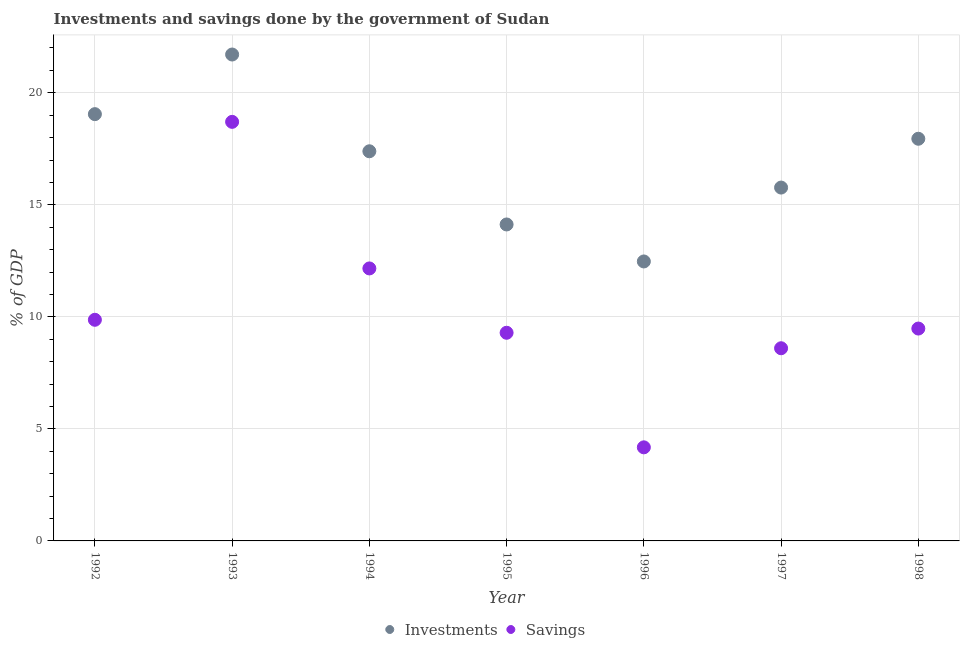How many different coloured dotlines are there?
Provide a succinct answer. 2. Is the number of dotlines equal to the number of legend labels?
Provide a short and direct response. Yes. What is the investments of government in 1992?
Offer a terse response. 19.05. Across all years, what is the maximum investments of government?
Keep it short and to the point. 21.71. Across all years, what is the minimum investments of government?
Your answer should be very brief. 12.47. In which year was the investments of government maximum?
Provide a succinct answer. 1993. In which year was the savings of government minimum?
Keep it short and to the point. 1996. What is the total savings of government in the graph?
Provide a short and direct response. 72.28. What is the difference between the savings of government in 1992 and that in 1995?
Your response must be concise. 0.58. What is the difference between the savings of government in 1993 and the investments of government in 1998?
Your answer should be very brief. 0.75. What is the average investments of government per year?
Ensure brevity in your answer.  16.92. In the year 1998, what is the difference between the savings of government and investments of government?
Offer a terse response. -8.47. What is the ratio of the savings of government in 1995 to that in 1997?
Offer a terse response. 1.08. Is the savings of government in 1994 less than that in 1995?
Your answer should be very brief. No. Is the difference between the savings of government in 1994 and 1997 greater than the difference between the investments of government in 1994 and 1997?
Your answer should be compact. Yes. What is the difference between the highest and the second highest savings of government?
Offer a very short reply. 6.54. What is the difference between the highest and the lowest investments of government?
Make the answer very short. 9.24. In how many years, is the savings of government greater than the average savings of government taken over all years?
Provide a succinct answer. 2. Does the savings of government monotonically increase over the years?
Provide a succinct answer. No. Is the investments of government strictly greater than the savings of government over the years?
Your answer should be very brief. Yes. How many dotlines are there?
Ensure brevity in your answer.  2. How many years are there in the graph?
Provide a short and direct response. 7. What is the difference between two consecutive major ticks on the Y-axis?
Keep it short and to the point. 5. Are the values on the major ticks of Y-axis written in scientific E-notation?
Keep it short and to the point. No. Does the graph contain grids?
Your answer should be compact. Yes. Where does the legend appear in the graph?
Offer a very short reply. Bottom center. How are the legend labels stacked?
Your response must be concise. Horizontal. What is the title of the graph?
Give a very brief answer. Investments and savings done by the government of Sudan. Does "From production" appear as one of the legend labels in the graph?
Ensure brevity in your answer.  No. What is the label or title of the Y-axis?
Offer a terse response. % of GDP. What is the % of GDP in Investments in 1992?
Your answer should be compact. 19.05. What is the % of GDP of Savings in 1992?
Ensure brevity in your answer.  9.87. What is the % of GDP of Investments in 1993?
Ensure brevity in your answer.  21.71. What is the % of GDP in Savings in 1993?
Provide a short and direct response. 18.7. What is the % of GDP of Investments in 1994?
Your answer should be very brief. 17.39. What is the % of GDP of Savings in 1994?
Keep it short and to the point. 12.16. What is the % of GDP in Investments in 1995?
Your response must be concise. 14.12. What is the % of GDP of Savings in 1995?
Your response must be concise. 9.29. What is the % of GDP of Investments in 1996?
Offer a terse response. 12.47. What is the % of GDP in Savings in 1996?
Ensure brevity in your answer.  4.18. What is the % of GDP of Investments in 1997?
Keep it short and to the point. 15.77. What is the % of GDP in Savings in 1997?
Offer a very short reply. 8.6. What is the % of GDP in Investments in 1998?
Ensure brevity in your answer.  17.95. What is the % of GDP in Savings in 1998?
Give a very brief answer. 9.48. Across all years, what is the maximum % of GDP in Investments?
Offer a very short reply. 21.71. Across all years, what is the maximum % of GDP in Savings?
Keep it short and to the point. 18.7. Across all years, what is the minimum % of GDP in Investments?
Your response must be concise. 12.47. Across all years, what is the minimum % of GDP in Savings?
Your response must be concise. 4.18. What is the total % of GDP of Investments in the graph?
Ensure brevity in your answer.  118.46. What is the total % of GDP in Savings in the graph?
Provide a succinct answer. 72.28. What is the difference between the % of GDP in Investments in 1992 and that in 1993?
Offer a terse response. -2.66. What is the difference between the % of GDP in Savings in 1992 and that in 1993?
Keep it short and to the point. -8.83. What is the difference between the % of GDP of Investments in 1992 and that in 1994?
Keep it short and to the point. 1.66. What is the difference between the % of GDP of Savings in 1992 and that in 1994?
Offer a terse response. -2.29. What is the difference between the % of GDP in Investments in 1992 and that in 1995?
Provide a succinct answer. 4.92. What is the difference between the % of GDP of Savings in 1992 and that in 1995?
Your answer should be compact. 0.58. What is the difference between the % of GDP in Investments in 1992 and that in 1996?
Give a very brief answer. 6.57. What is the difference between the % of GDP in Savings in 1992 and that in 1996?
Make the answer very short. 5.69. What is the difference between the % of GDP in Investments in 1992 and that in 1997?
Your answer should be very brief. 3.28. What is the difference between the % of GDP in Savings in 1992 and that in 1997?
Offer a terse response. 1.27. What is the difference between the % of GDP in Investments in 1992 and that in 1998?
Keep it short and to the point. 1.1. What is the difference between the % of GDP of Savings in 1992 and that in 1998?
Your answer should be compact. 0.39. What is the difference between the % of GDP of Investments in 1993 and that in 1994?
Ensure brevity in your answer.  4.32. What is the difference between the % of GDP of Savings in 1993 and that in 1994?
Give a very brief answer. 6.54. What is the difference between the % of GDP in Investments in 1993 and that in 1995?
Your answer should be compact. 7.59. What is the difference between the % of GDP of Savings in 1993 and that in 1995?
Your response must be concise. 9.41. What is the difference between the % of GDP of Investments in 1993 and that in 1996?
Make the answer very short. 9.24. What is the difference between the % of GDP in Savings in 1993 and that in 1996?
Your answer should be compact. 14.53. What is the difference between the % of GDP in Investments in 1993 and that in 1997?
Offer a very short reply. 5.94. What is the difference between the % of GDP in Savings in 1993 and that in 1997?
Your response must be concise. 10.1. What is the difference between the % of GDP of Investments in 1993 and that in 1998?
Your answer should be compact. 3.76. What is the difference between the % of GDP of Savings in 1993 and that in 1998?
Offer a terse response. 9.23. What is the difference between the % of GDP in Investments in 1994 and that in 1995?
Provide a succinct answer. 3.27. What is the difference between the % of GDP in Savings in 1994 and that in 1995?
Give a very brief answer. 2.87. What is the difference between the % of GDP in Investments in 1994 and that in 1996?
Your answer should be compact. 4.92. What is the difference between the % of GDP of Savings in 1994 and that in 1996?
Offer a terse response. 7.98. What is the difference between the % of GDP in Investments in 1994 and that in 1997?
Offer a terse response. 1.62. What is the difference between the % of GDP in Savings in 1994 and that in 1997?
Ensure brevity in your answer.  3.56. What is the difference between the % of GDP in Investments in 1994 and that in 1998?
Offer a very short reply. -0.56. What is the difference between the % of GDP in Savings in 1994 and that in 1998?
Your answer should be very brief. 2.68. What is the difference between the % of GDP of Investments in 1995 and that in 1996?
Make the answer very short. 1.65. What is the difference between the % of GDP in Savings in 1995 and that in 1996?
Keep it short and to the point. 5.11. What is the difference between the % of GDP in Investments in 1995 and that in 1997?
Provide a short and direct response. -1.65. What is the difference between the % of GDP of Savings in 1995 and that in 1997?
Offer a terse response. 0.69. What is the difference between the % of GDP of Investments in 1995 and that in 1998?
Your answer should be very brief. -3.83. What is the difference between the % of GDP in Savings in 1995 and that in 1998?
Keep it short and to the point. -0.19. What is the difference between the % of GDP in Investments in 1996 and that in 1997?
Offer a very short reply. -3.3. What is the difference between the % of GDP of Savings in 1996 and that in 1997?
Ensure brevity in your answer.  -4.42. What is the difference between the % of GDP of Investments in 1996 and that in 1998?
Ensure brevity in your answer.  -5.48. What is the difference between the % of GDP in Savings in 1996 and that in 1998?
Provide a short and direct response. -5.3. What is the difference between the % of GDP of Investments in 1997 and that in 1998?
Provide a short and direct response. -2.18. What is the difference between the % of GDP of Savings in 1997 and that in 1998?
Provide a short and direct response. -0.88. What is the difference between the % of GDP in Investments in 1992 and the % of GDP in Savings in 1993?
Offer a terse response. 0.34. What is the difference between the % of GDP of Investments in 1992 and the % of GDP of Savings in 1994?
Give a very brief answer. 6.89. What is the difference between the % of GDP in Investments in 1992 and the % of GDP in Savings in 1995?
Provide a succinct answer. 9.76. What is the difference between the % of GDP in Investments in 1992 and the % of GDP in Savings in 1996?
Your answer should be very brief. 14.87. What is the difference between the % of GDP in Investments in 1992 and the % of GDP in Savings in 1997?
Ensure brevity in your answer.  10.45. What is the difference between the % of GDP in Investments in 1992 and the % of GDP in Savings in 1998?
Ensure brevity in your answer.  9.57. What is the difference between the % of GDP of Investments in 1993 and the % of GDP of Savings in 1994?
Provide a short and direct response. 9.55. What is the difference between the % of GDP in Investments in 1993 and the % of GDP in Savings in 1995?
Give a very brief answer. 12.42. What is the difference between the % of GDP in Investments in 1993 and the % of GDP in Savings in 1996?
Keep it short and to the point. 17.53. What is the difference between the % of GDP in Investments in 1993 and the % of GDP in Savings in 1997?
Give a very brief answer. 13.11. What is the difference between the % of GDP in Investments in 1993 and the % of GDP in Savings in 1998?
Give a very brief answer. 12.23. What is the difference between the % of GDP in Investments in 1994 and the % of GDP in Savings in 1995?
Offer a terse response. 8.1. What is the difference between the % of GDP of Investments in 1994 and the % of GDP of Savings in 1996?
Give a very brief answer. 13.21. What is the difference between the % of GDP of Investments in 1994 and the % of GDP of Savings in 1997?
Your answer should be compact. 8.79. What is the difference between the % of GDP of Investments in 1994 and the % of GDP of Savings in 1998?
Ensure brevity in your answer.  7.91. What is the difference between the % of GDP of Investments in 1995 and the % of GDP of Savings in 1996?
Provide a short and direct response. 9.95. What is the difference between the % of GDP in Investments in 1995 and the % of GDP in Savings in 1997?
Offer a terse response. 5.52. What is the difference between the % of GDP of Investments in 1995 and the % of GDP of Savings in 1998?
Your answer should be very brief. 4.65. What is the difference between the % of GDP in Investments in 1996 and the % of GDP in Savings in 1997?
Your answer should be compact. 3.87. What is the difference between the % of GDP in Investments in 1996 and the % of GDP in Savings in 1998?
Your answer should be very brief. 2.99. What is the difference between the % of GDP of Investments in 1997 and the % of GDP of Savings in 1998?
Offer a terse response. 6.29. What is the average % of GDP in Investments per year?
Your answer should be very brief. 16.92. What is the average % of GDP in Savings per year?
Provide a succinct answer. 10.33. In the year 1992, what is the difference between the % of GDP of Investments and % of GDP of Savings?
Your answer should be very brief. 9.18. In the year 1993, what is the difference between the % of GDP of Investments and % of GDP of Savings?
Your answer should be compact. 3.01. In the year 1994, what is the difference between the % of GDP of Investments and % of GDP of Savings?
Offer a very short reply. 5.23. In the year 1995, what is the difference between the % of GDP in Investments and % of GDP in Savings?
Ensure brevity in your answer.  4.83. In the year 1996, what is the difference between the % of GDP in Investments and % of GDP in Savings?
Make the answer very short. 8.3. In the year 1997, what is the difference between the % of GDP in Investments and % of GDP in Savings?
Your response must be concise. 7.17. In the year 1998, what is the difference between the % of GDP in Investments and % of GDP in Savings?
Offer a very short reply. 8.47. What is the ratio of the % of GDP of Investments in 1992 to that in 1993?
Make the answer very short. 0.88. What is the ratio of the % of GDP of Savings in 1992 to that in 1993?
Your response must be concise. 0.53. What is the ratio of the % of GDP in Investments in 1992 to that in 1994?
Offer a terse response. 1.1. What is the ratio of the % of GDP in Savings in 1992 to that in 1994?
Offer a very short reply. 0.81. What is the ratio of the % of GDP in Investments in 1992 to that in 1995?
Give a very brief answer. 1.35. What is the ratio of the % of GDP of Savings in 1992 to that in 1995?
Keep it short and to the point. 1.06. What is the ratio of the % of GDP of Investments in 1992 to that in 1996?
Offer a terse response. 1.53. What is the ratio of the % of GDP of Savings in 1992 to that in 1996?
Your answer should be compact. 2.36. What is the ratio of the % of GDP of Investments in 1992 to that in 1997?
Provide a succinct answer. 1.21. What is the ratio of the % of GDP in Savings in 1992 to that in 1997?
Provide a short and direct response. 1.15. What is the ratio of the % of GDP of Investments in 1992 to that in 1998?
Offer a very short reply. 1.06. What is the ratio of the % of GDP of Savings in 1992 to that in 1998?
Provide a short and direct response. 1.04. What is the ratio of the % of GDP of Investments in 1993 to that in 1994?
Make the answer very short. 1.25. What is the ratio of the % of GDP of Savings in 1993 to that in 1994?
Offer a very short reply. 1.54. What is the ratio of the % of GDP of Investments in 1993 to that in 1995?
Your answer should be compact. 1.54. What is the ratio of the % of GDP of Savings in 1993 to that in 1995?
Keep it short and to the point. 2.01. What is the ratio of the % of GDP of Investments in 1993 to that in 1996?
Provide a short and direct response. 1.74. What is the ratio of the % of GDP in Savings in 1993 to that in 1996?
Offer a terse response. 4.48. What is the ratio of the % of GDP in Investments in 1993 to that in 1997?
Provide a short and direct response. 1.38. What is the ratio of the % of GDP in Savings in 1993 to that in 1997?
Your answer should be very brief. 2.17. What is the ratio of the % of GDP of Investments in 1993 to that in 1998?
Your answer should be compact. 1.21. What is the ratio of the % of GDP of Savings in 1993 to that in 1998?
Offer a very short reply. 1.97. What is the ratio of the % of GDP of Investments in 1994 to that in 1995?
Provide a succinct answer. 1.23. What is the ratio of the % of GDP of Savings in 1994 to that in 1995?
Make the answer very short. 1.31. What is the ratio of the % of GDP of Investments in 1994 to that in 1996?
Offer a terse response. 1.39. What is the ratio of the % of GDP of Savings in 1994 to that in 1996?
Provide a succinct answer. 2.91. What is the ratio of the % of GDP of Investments in 1994 to that in 1997?
Give a very brief answer. 1.1. What is the ratio of the % of GDP in Savings in 1994 to that in 1997?
Keep it short and to the point. 1.41. What is the ratio of the % of GDP of Investments in 1994 to that in 1998?
Offer a very short reply. 0.97. What is the ratio of the % of GDP of Savings in 1994 to that in 1998?
Provide a short and direct response. 1.28. What is the ratio of the % of GDP in Investments in 1995 to that in 1996?
Provide a succinct answer. 1.13. What is the ratio of the % of GDP in Savings in 1995 to that in 1996?
Offer a very short reply. 2.22. What is the ratio of the % of GDP of Investments in 1995 to that in 1997?
Give a very brief answer. 0.9. What is the ratio of the % of GDP in Savings in 1995 to that in 1997?
Offer a terse response. 1.08. What is the ratio of the % of GDP in Investments in 1995 to that in 1998?
Your response must be concise. 0.79. What is the ratio of the % of GDP of Savings in 1995 to that in 1998?
Offer a terse response. 0.98. What is the ratio of the % of GDP of Investments in 1996 to that in 1997?
Your answer should be compact. 0.79. What is the ratio of the % of GDP of Savings in 1996 to that in 1997?
Make the answer very short. 0.49. What is the ratio of the % of GDP in Investments in 1996 to that in 1998?
Keep it short and to the point. 0.69. What is the ratio of the % of GDP in Savings in 1996 to that in 1998?
Your answer should be compact. 0.44. What is the ratio of the % of GDP of Investments in 1997 to that in 1998?
Make the answer very short. 0.88. What is the ratio of the % of GDP of Savings in 1997 to that in 1998?
Offer a very short reply. 0.91. What is the difference between the highest and the second highest % of GDP of Investments?
Offer a terse response. 2.66. What is the difference between the highest and the second highest % of GDP in Savings?
Ensure brevity in your answer.  6.54. What is the difference between the highest and the lowest % of GDP in Investments?
Your answer should be very brief. 9.24. What is the difference between the highest and the lowest % of GDP of Savings?
Offer a terse response. 14.53. 